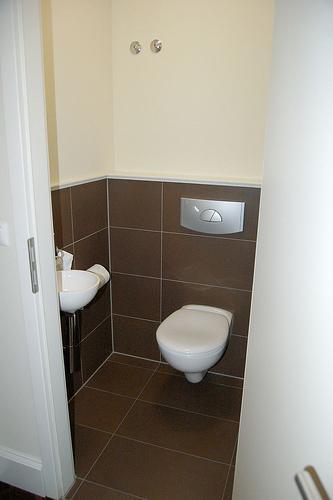How many toilets are there?
Give a very brief answer. 1. 